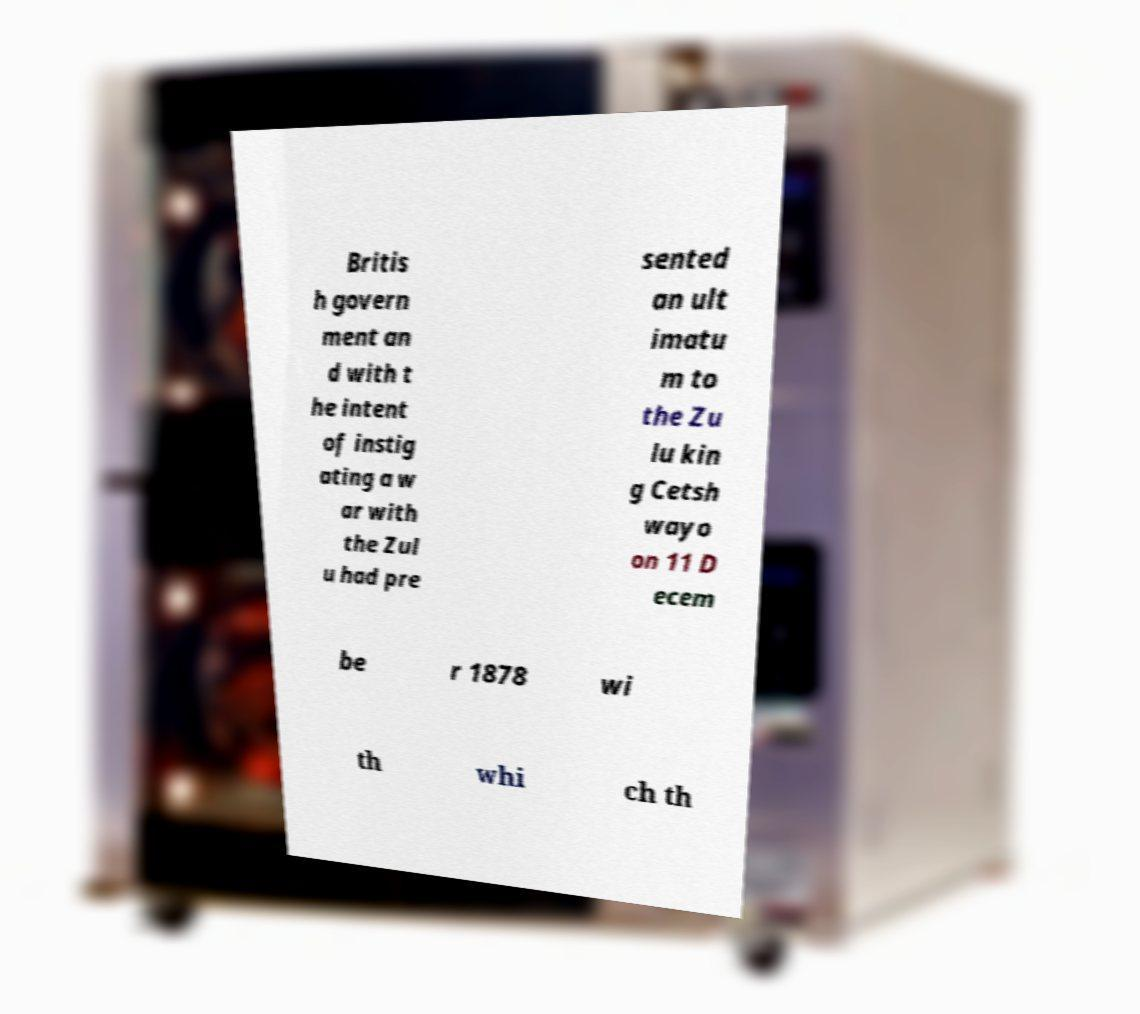Could you assist in decoding the text presented in this image and type it out clearly? Britis h govern ment an d with t he intent of instig ating a w ar with the Zul u had pre sented an ult imatu m to the Zu lu kin g Cetsh wayo on 11 D ecem be r 1878 wi th whi ch th 